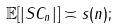<formula> <loc_0><loc_0><loc_500><loc_500>\mathbb { E } [ | S C _ { n } | ] \asymp s ( n ) ;</formula> 